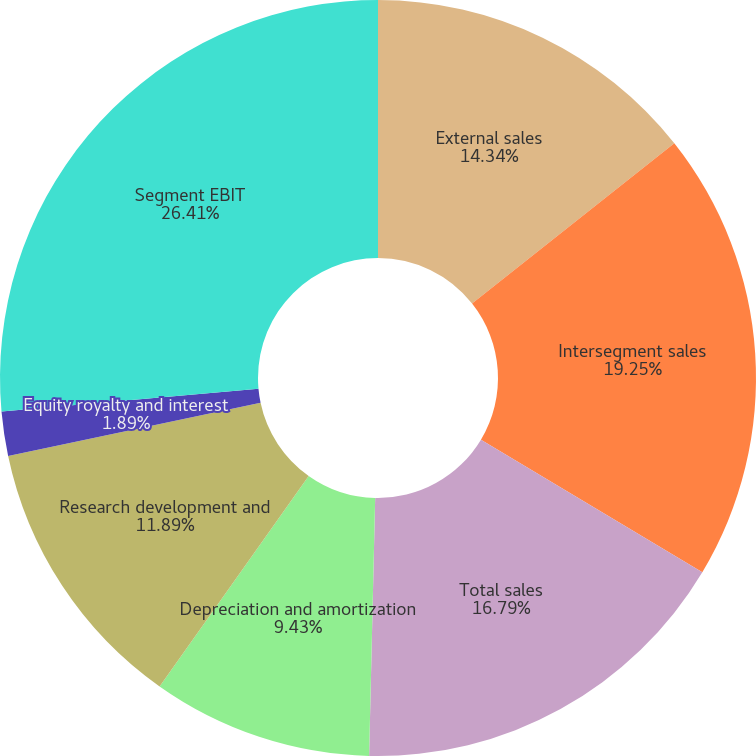<chart> <loc_0><loc_0><loc_500><loc_500><pie_chart><fcel>External sales<fcel>Intersegment sales<fcel>Total sales<fcel>Depreciation and amortization<fcel>Research development and<fcel>Equity royalty and interest<fcel>Segment EBIT<nl><fcel>14.34%<fcel>19.25%<fcel>16.79%<fcel>9.43%<fcel>11.89%<fcel>1.89%<fcel>26.42%<nl></chart> 